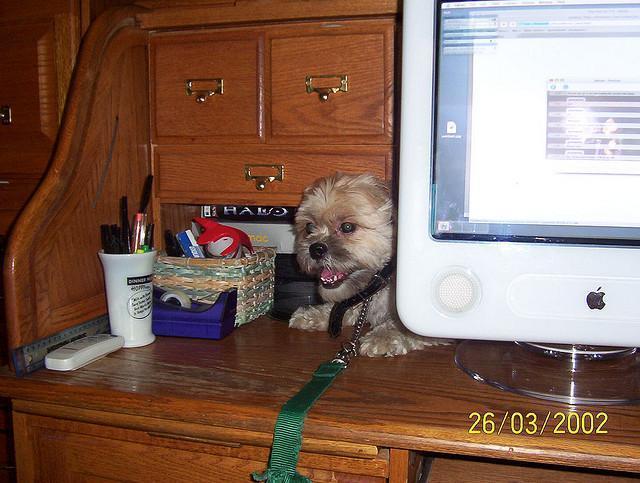How many remote controls are in the photo?
Give a very brief answer. 1. How many white cars are there?
Give a very brief answer. 0. 